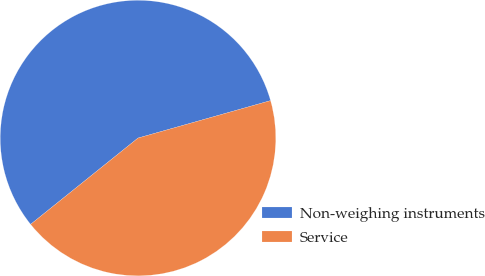Convert chart. <chart><loc_0><loc_0><loc_500><loc_500><pie_chart><fcel>Non-weighing instruments<fcel>Service<nl><fcel>56.39%<fcel>43.61%<nl></chart> 